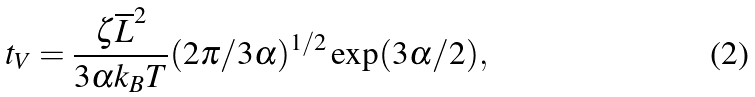<formula> <loc_0><loc_0><loc_500><loc_500>t _ { V } = \frac { \zeta \overline { L } ^ { 2 } } { 3 \alpha k _ { B } T } ( 2 \pi / 3 \alpha ) ^ { 1 / 2 } \exp ( 3 \alpha / 2 ) ,</formula> 